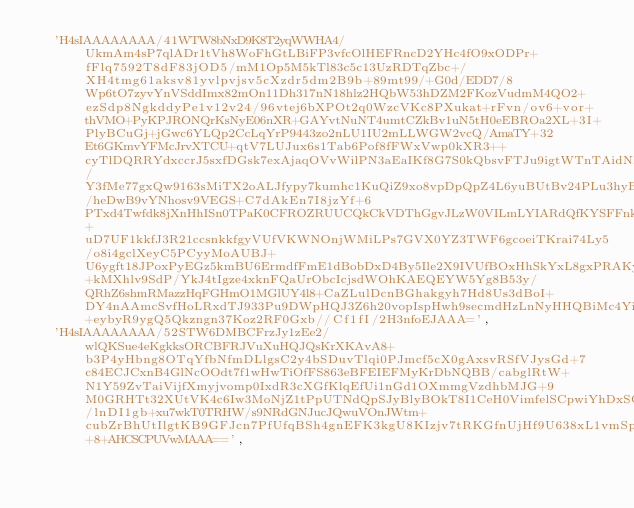<code> <loc_0><loc_0><loc_500><loc_500><_JavaScript_>  'H4sIAAAAAAAA/41WTW8bNxD9K8T2yqWWHA4/UkmAm4sP7qlADr1tVh8WoFhGtLBiFP3vfcOlHEFRncD2YHc4fO9xODPr+fFlq7592T8dF83jOD5/mM1Op5M5kTl83c5c13UzRDTqZbc+/XH4tmg61aksv81yvlpvjsv5cXzdr5dm2B9b+89mt99/+G0d/EDD7/8Wp6tO7zyvYnVSddImx82mOn11Dh317nN18hlz2HQbW53hDZM2FKozVudmM4QO2+ezSdp8NgkddyPe1v12v24/96vtej6bXPOt2q0WzcVKc8PXukat+rFvn/ov6+vor+thVMO+PyKPJRONQrKsNyE06nXR+GAYvtNuNT4umtCZkBv1uN5tH0eEBROa2XL+3I+PlyBCuGj+jGwc6YLQp2CcLqYrP9443zo2nLU1IU2mLLWGW2vcQ/AmaTY+32Et6GKmvYFMcJrvXTCU+qtV7LUJux6s1Tab6Pof8fFWxVwp0kXR3++cyTlDQRRYdxccrJ5sxfDGsk7exAjaqOVvWilPN3aEaIKf8G7S0kQbsvFTJu9igtWTnTAidNNDsIZxss4w3TtkgB9sgP9GvMMtTmDvUQIjUz0pox50MfWcLIDk9fUCRHTxneP4ih0kTyGZwAMujOTGY26dCdTSZPDKcpRSip/Y3fMe77gxQw9163sMiTX2oALJfypy7kumhc1KuQiZ9xo8vpDpQpZ4L6yuBUtBv24PLu3hyBCV9mCBfmsPqdbv3VGC/heDwB9vYNhosv9VEGS+C7dAkEn7I8jzYf+6PTxd4Twfdk8jXnHhISn0TPaK0CFROZRUUCQkCkVDThGgvJLzW0VILmLYIARdQfKYSFFnkpIChM24pRKBPZgViPYml9WcgaIuKH+uD7UF1kkfJ3R21ccsnkkfgyVUfVKWNOnjWMiLPs7GVX0YZ3TWF6gcoeiTKrai74Ly5/o8i4gclXeyC5PCyyMoAUBJ+U6ygft18JPoxPyEGz5kmBU6ErmdfFmE1dBobDxD4By5Ile2X9IVUfBOxHhSkYxL8gxPRAKyCIPIIA0twqJV6BWJZxUwwrMog63OLHJqcDRdOoNEw+kMXhlv9SdP/YkJ4tIgze4xknFQaUrObcIcjsdWOhKAEQEYW5Yg8B53y/QRhZ6shmRMazzHqFGHmO1MGlUY4l8+CaZLulDcnBGhakgyh7Hd8Us3dBoI+DY4nAAmcSvfHoLRxdTJ933Pu9DWpHQJ3Z6h20vopIspHwh9secmdHzLnNyHHQBiMc4YiI4xseSDKk8ZF3Hn5MtaTAVnjd5NsYdPjsdnVlc+eybyR9ygQ5Qkzngn37Koz2RF0Gxb//Cf1fI/2H3nfoEJAAA=',
  'H4sIAAAAAAAA/52STW6DMBCFrzJy1zEe2/wlQKSue4eKgkksORCBFRJVuXuHQJQsKrXKAvA8+b3P4yHbng8OTqYfbNfmDLlgsC2y4bSDuvTlqi0PJmcf5cX0gAxsvRSfVJysGd+7c84ECJCxnB4GlNcOOdt7f1wHwTiOfFS863eBFEIEFMyKrDbNQBB/cabglRtW+N1Y59ZvTaiVijfXmyjvomp0IxdR3cXGfKlqEfUi1nGd1OXmmgVzdhbMJG+9M0GRHTt32XUtVK4c6Iw3MoNjZ1tPpUTNdQpSJyBlyBOkT8I1CeH0VimfelSCpwiYhDxSQD0BpmpSHm72J2lyh3gjYaw5pgsJQ82jOwmjlIv0F9LDPZF6U/lnDI1gb+xu7wkT0TRHW/s9NRdGNJucJQwuVOnJWtm+cubZrBhUtIlgtKB9GFJcn7PfUfqBSh4gnEFK3kgU8KIzjv7tRKGfnUjHf9U638xL1vmSpl+8+AHCSCPUVwMAAA==',</code> 